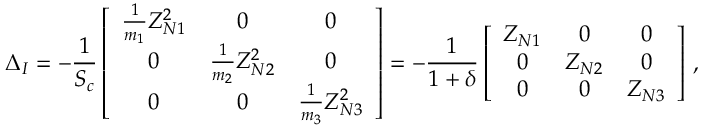Convert formula to latex. <formula><loc_0><loc_0><loc_500><loc_500>\Delta _ { I } = - \frac { 1 } { S _ { c } } \left [ \begin{array} { c c c } { \frac { 1 } { m _ { 1 } } Z _ { N 1 } ^ { 2 } } & { 0 } & { 0 } \\ { 0 } & { \frac { 1 } { m _ { 2 } } Z _ { N 2 } ^ { 2 } } & { 0 } \\ { 0 } & { 0 } & { \frac { 1 } { m _ { 3 } } Z _ { N 3 } ^ { 2 } } \end{array} \right ] = - \frac { 1 } { 1 + \delta } \left [ \begin{array} { c c c } { Z _ { N 1 } } & { 0 } & { 0 } \\ { 0 } & { Z _ { N 2 } } & { 0 } \\ { 0 } & { 0 } & { Z _ { N 3 } } \end{array} \right ] \, ,</formula> 